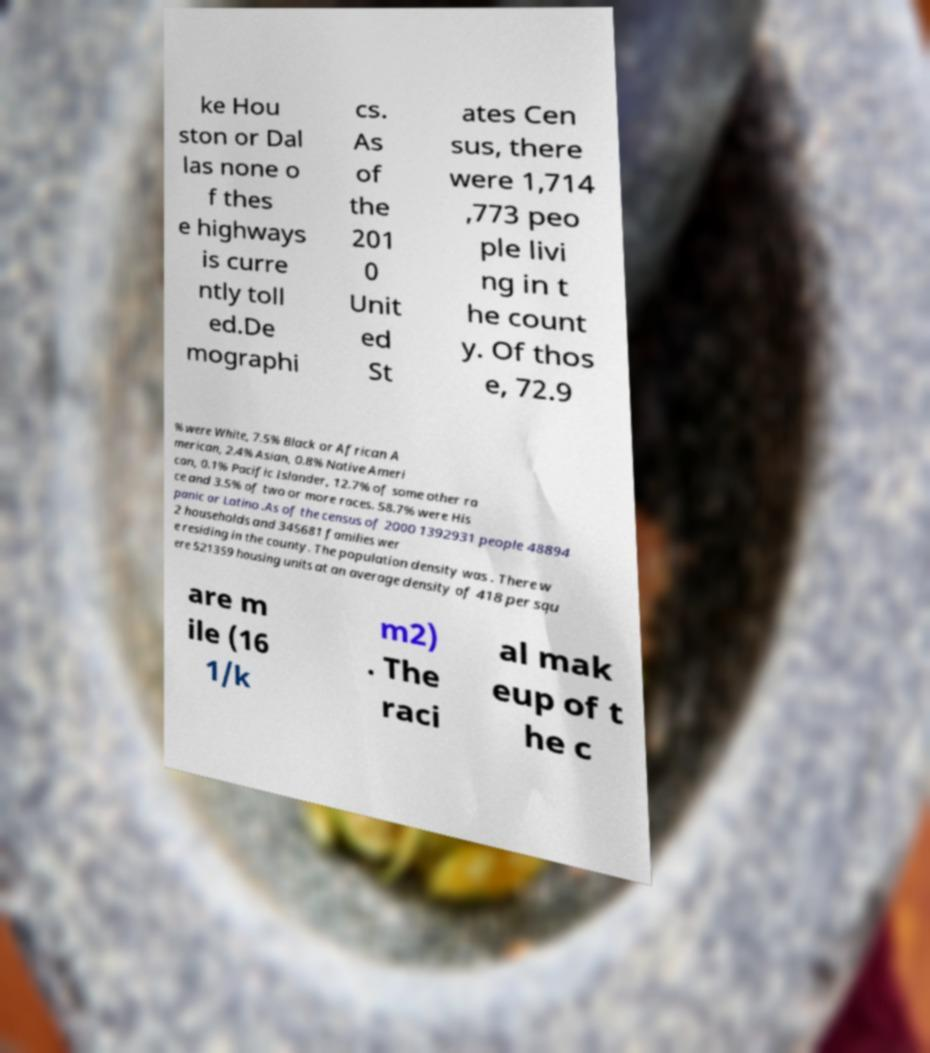What messages or text are displayed in this image? I need them in a readable, typed format. ke Hou ston or Dal las none o f thes e highways is curre ntly toll ed.De mographi cs. As of the 201 0 Unit ed St ates Cen sus, there were 1,714 ,773 peo ple livi ng in t he count y. Of thos e, 72.9 % were White, 7.5% Black or African A merican, 2.4% Asian, 0.8% Native Ameri can, 0.1% Pacific Islander, 12.7% of some other ra ce and 3.5% of two or more races. 58.7% were His panic or Latino .As of the census of 2000 1392931 people 48894 2 households and 345681 families wer e residing in the county. The population density was . There w ere 521359 housing units at an average density of 418 per squ are m ile (16 1/k m2) . The raci al mak eup of t he c 